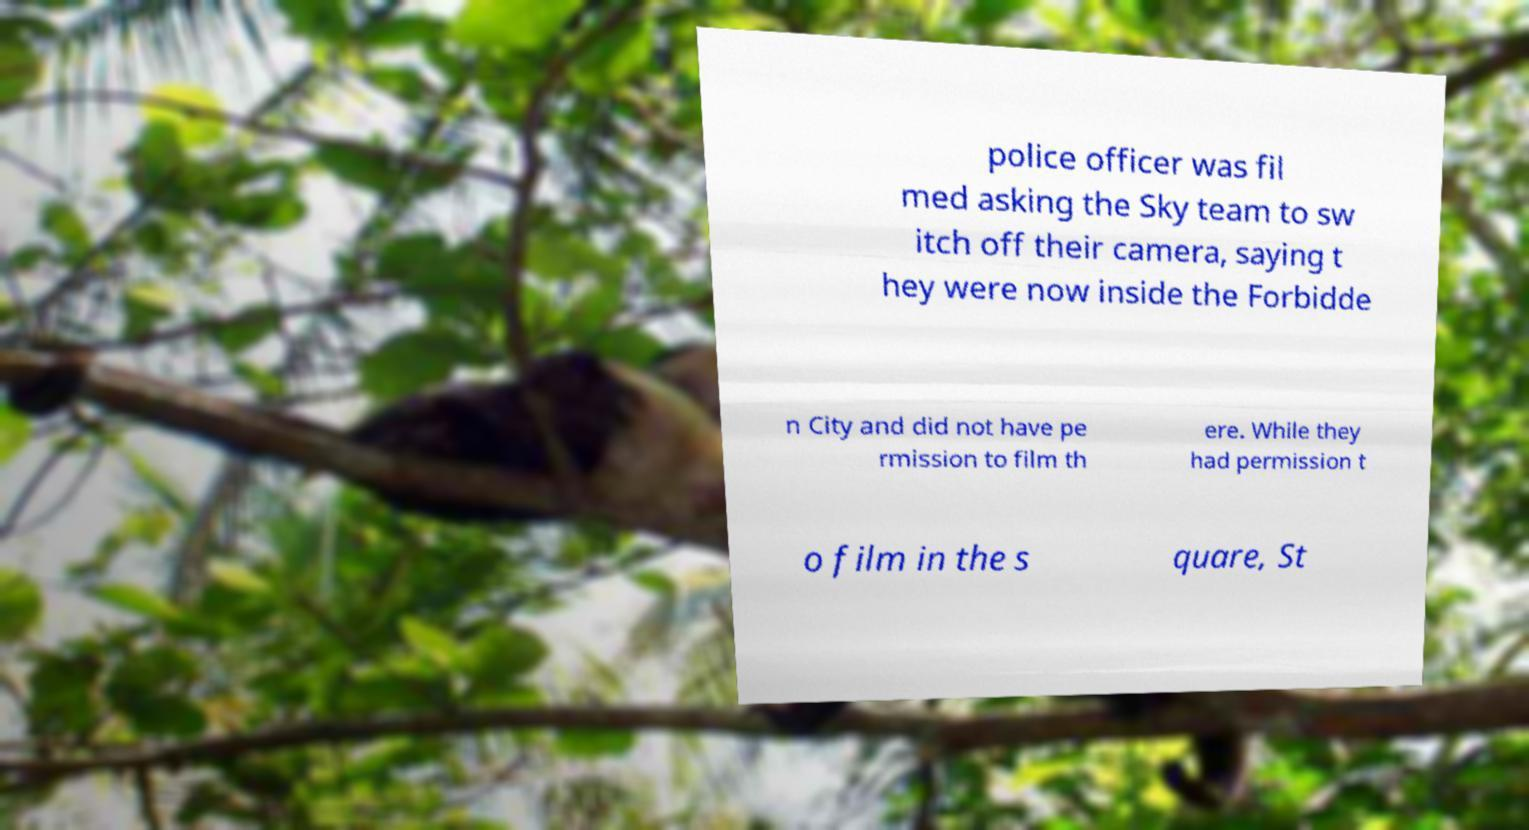Can you read and provide the text displayed in the image?This photo seems to have some interesting text. Can you extract and type it out for me? police officer was fil med asking the Sky team to sw itch off their camera, saying t hey were now inside the Forbidde n City and did not have pe rmission to film th ere. While they had permission t o film in the s quare, St 